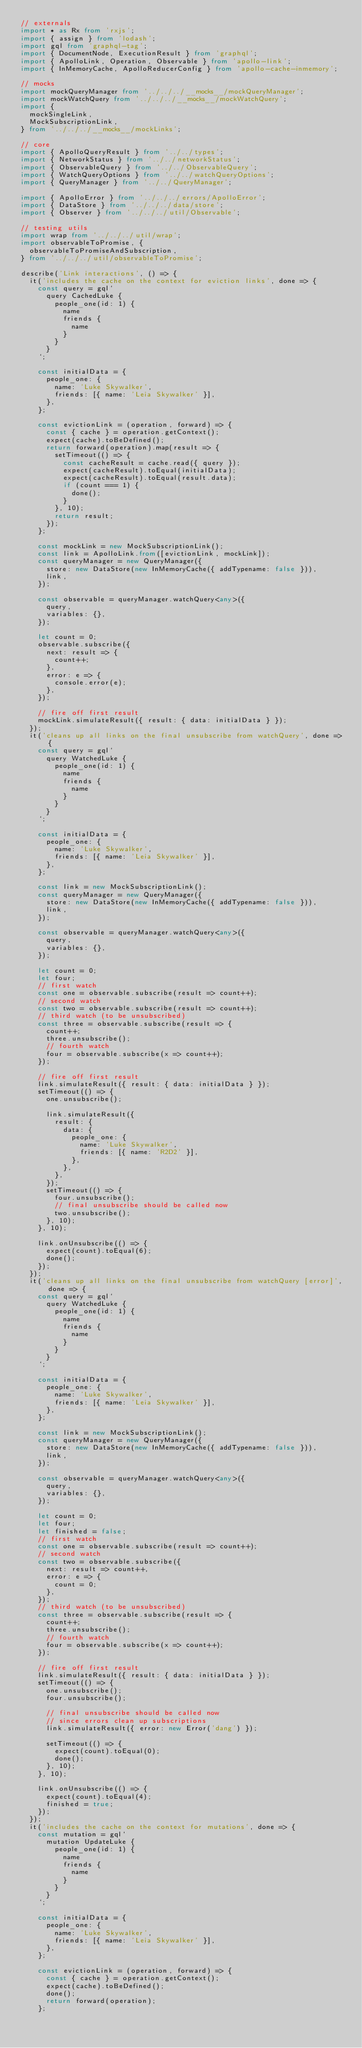<code> <loc_0><loc_0><loc_500><loc_500><_TypeScript_>// externals
import * as Rx from 'rxjs';
import { assign } from 'lodash';
import gql from 'graphql-tag';
import { DocumentNode, ExecutionResult } from 'graphql';
import { ApolloLink, Operation, Observable } from 'apollo-link';
import { InMemoryCache, ApolloReducerConfig } from 'apollo-cache-inmemory';

// mocks
import mockQueryManager from '../../../__mocks__/mockQueryManager';
import mockWatchQuery from '../../../__mocks__/mockWatchQuery';
import {
  mockSingleLink,
  MockSubscriptionLink,
} from '../../../__mocks__/mockLinks';

// core
import { ApolloQueryResult } from '../../types';
import { NetworkStatus } from '../../networkStatus';
import { ObservableQuery } from '../../ObservableQuery';
import { WatchQueryOptions } from '../../watchQueryOptions';
import { QueryManager } from '../../QueryManager';

import { ApolloError } from '../../../errors/ApolloError';
import { DataStore } from '../../../data/store';
import { Observer } from '../../../util/Observable';

// testing utils
import wrap from '../../../util/wrap';
import observableToPromise, {
  observableToPromiseAndSubscription,
} from '../../../util/observableToPromise';

describe('Link interactions', () => {
  it('includes the cache on the context for eviction links', done => {
    const query = gql`
      query CachedLuke {
        people_one(id: 1) {
          name
          friends {
            name
          }
        }
      }
    `;

    const initialData = {
      people_one: {
        name: 'Luke Skywalker',
        friends: [{ name: 'Leia Skywalker' }],
      },
    };

    const evictionLink = (operation, forward) => {
      const { cache } = operation.getContext();
      expect(cache).toBeDefined();
      return forward(operation).map(result => {
        setTimeout(() => {
          const cacheResult = cache.read({ query });
          expect(cacheResult).toEqual(initialData);
          expect(cacheResult).toEqual(result.data);
          if (count === 1) {
            done();
          }
        }, 10);
        return result;
      });
    };

    const mockLink = new MockSubscriptionLink();
    const link = ApolloLink.from([evictionLink, mockLink]);
    const queryManager = new QueryManager({
      store: new DataStore(new InMemoryCache({ addTypename: false })),
      link,
    });

    const observable = queryManager.watchQuery<any>({
      query,
      variables: {},
    });

    let count = 0;
    observable.subscribe({
      next: result => {
        count++;
      },
      error: e => {
        console.error(e);
      },
    });

    // fire off first result
    mockLink.simulateResult({ result: { data: initialData } });
  });
  it('cleans up all links on the final unsubscribe from watchQuery', done => {
    const query = gql`
      query WatchedLuke {
        people_one(id: 1) {
          name
          friends {
            name
          }
        }
      }
    `;

    const initialData = {
      people_one: {
        name: 'Luke Skywalker',
        friends: [{ name: 'Leia Skywalker' }],
      },
    };

    const link = new MockSubscriptionLink();
    const queryManager = new QueryManager({
      store: new DataStore(new InMemoryCache({ addTypename: false })),
      link,
    });

    const observable = queryManager.watchQuery<any>({
      query,
      variables: {},
    });

    let count = 0;
    let four;
    // first watch
    const one = observable.subscribe(result => count++);
    // second watch
    const two = observable.subscribe(result => count++);
    // third watch (to be unsubscribed)
    const three = observable.subscribe(result => {
      count++;
      three.unsubscribe();
      // fourth watch
      four = observable.subscribe(x => count++);
    });

    // fire off first result
    link.simulateResult({ result: { data: initialData } });
    setTimeout(() => {
      one.unsubscribe();

      link.simulateResult({
        result: {
          data: {
            people_one: {
              name: 'Luke Skywalker',
              friends: [{ name: 'R2D2' }],
            },
          },
        },
      });
      setTimeout(() => {
        four.unsubscribe();
        // final unsubscribe should be called now
        two.unsubscribe();
      }, 10);
    }, 10);

    link.onUnsubscribe(() => {
      expect(count).toEqual(6);
      done();
    });
  });
  it('cleans up all links on the final unsubscribe from watchQuery [error]', done => {
    const query = gql`
      query WatchedLuke {
        people_one(id: 1) {
          name
          friends {
            name
          }
        }
      }
    `;

    const initialData = {
      people_one: {
        name: 'Luke Skywalker',
        friends: [{ name: 'Leia Skywalker' }],
      },
    };

    const link = new MockSubscriptionLink();
    const queryManager = new QueryManager({
      store: new DataStore(new InMemoryCache({ addTypename: false })),
      link,
    });

    const observable = queryManager.watchQuery<any>({
      query,
      variables: {},
    });

    let count = 0;
    let four;
    let finished = false;
    // first watch
    const one = observable.subscribe(result => count++);
    // second watch
    const two = observable.subscribe({
      next: result => count++,
      error: e => {
        count = 0;
      },
    });
    // third watch (to be unsubscribed)
    const three = observable.subscribe(result => {
      count++;
      three.unsubscribe();
      // fourth watch
      four = observable.subscribe(x => count++);
    });

    // fire off first result
    link.simulateResult({ result: { data: initialData } });
    setTimeout(() => {
      one.unsubscribe();
      four.unsubscribe();

      // final unsubscribe should be called now
      // since errors clean up subscriptions
      link.simulateResult({ error: new Error('dang') });

      setTimeout(() => {
        expect(count).toEqual(0);
        done();
      }, 10);
    }, 10);

    link.onUnsubscribe(() => {
      expect(count).toEqual(4);
      finished = true;
    });
  });
  it('includes the cache on the context for mutations', done => {
    const mutation = gql`
      mutation UpdateLuke {
        people_one(id: 1) {
          name
          friends {
            name
          }
        }
      }
    `;

    const initialData = {
      people_one: {
        name: 'Luke Skywalker',
        friends: [{ name: 'Leia Skywalker' }],
      },
    };

    const evictionLink = (operation, forward) => {
      const { cache } = operation.getContext();
      expect(cache).toBeDefined();
      done();
      return forward(operation);
    };
</code> 